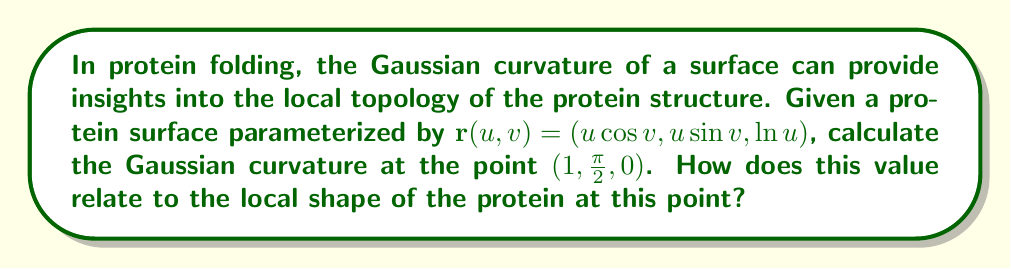Help me with this question. To find the Gaussian curvature, we'll follow these steps:

1) First, we need to calculate the partial derivatives:
   $\mathbf{r}_u = (\cos v, \sin v, \frac{1}{u})$
   $\mathbf{r}_v = (-u\sin v, u\cos v, 0)$

2) Now, we calculate the second partial derivatives:
   $\mathbf{r}_{uu} = (0, 0, -\frac{1}{u^2})$
   $\mathbf{r}_{uv} = (-\sin v, \cos v, 0)$
   $\mathbf{r}_{vv} = (-u\cos v, -u\sin v, 0)$

3) We need to calculate the normal vector:
   $\mathbf{N} = \frac{\mathbf{r}_u \times \mathbf{r}_v}{|\mathbf{r}_u \times \mathbf{r}_v|}$
   
   $\mathbf{r}_u \times \mathbf{r}_v = (u\sin^2 v + u\cos^2 v, -u\cos v\sin v + u\sin v\cos v, -u\cos^2 v - u\sin^2 v)$
                                    $= (u, 0, -u)$
   
   $|\mathbf{r}_u \times \mathbf{r}_v| = \sqrt{u^2 + u^2} = u\sqrt{2}$
   
   Therefore, $\mathbf{N} = (\frac{1}{\sqrt{2}}, 0, -\frac{1}{\sqrt{2}})$

4) Now we can calculate the coefficients of the first and second fundamental forms:
   $E = \mathbf{r}_u \cdot \mathbf{r}_u = \cos^2 v + \sin^2 v + \frac{1}{u^2} = 1 + \frac{1}{u^2}$
   $F = \mathbf{r}_u \cdot \mathbf{r}_v = 0$
   $G = \mathbf{r}_v \cdot \mathbf{r}_v = u^2$
   
   $L = \mathbf{r}_{uu} \cdot \mathbf{N} = -\frac{1}{u^2} \cdot (-\frac{1}{\sqrt{2}}) = \frac{1}{u^2\sqrt{2}}$
   $M = \mathbf{r}_{uv} \cdot \mathbf{N} = 0$
   $N = \mathbf{r}_{vv} \cdot \mathbf{N} = -u\cos v \cdot \frac{1}{\sqrt{2}} - (-u\sin v) \cdot 0 = -\frac{u\cos v}{\sqrt{2}}$

5) The Gaussian curvature is given by:
   $K = \frac{LN - M^2}{EG - F^2}$

6) Substituting the values at the point $(1,\frac{\pi}{2},0)$:
   $K = \frac{(\frac{1}{\sqrt{2}})(0) - 0^2}{(2)(1) - 0^2} = 0$

7) A Gaussian curvature of 0 indicates that the surface at this point is locally flat in at least one direction. This could represent a saddle point or a cylindrical section in the protein structure.
Answer: $K = 0$, indicating a locally flat or saddle-like structure 